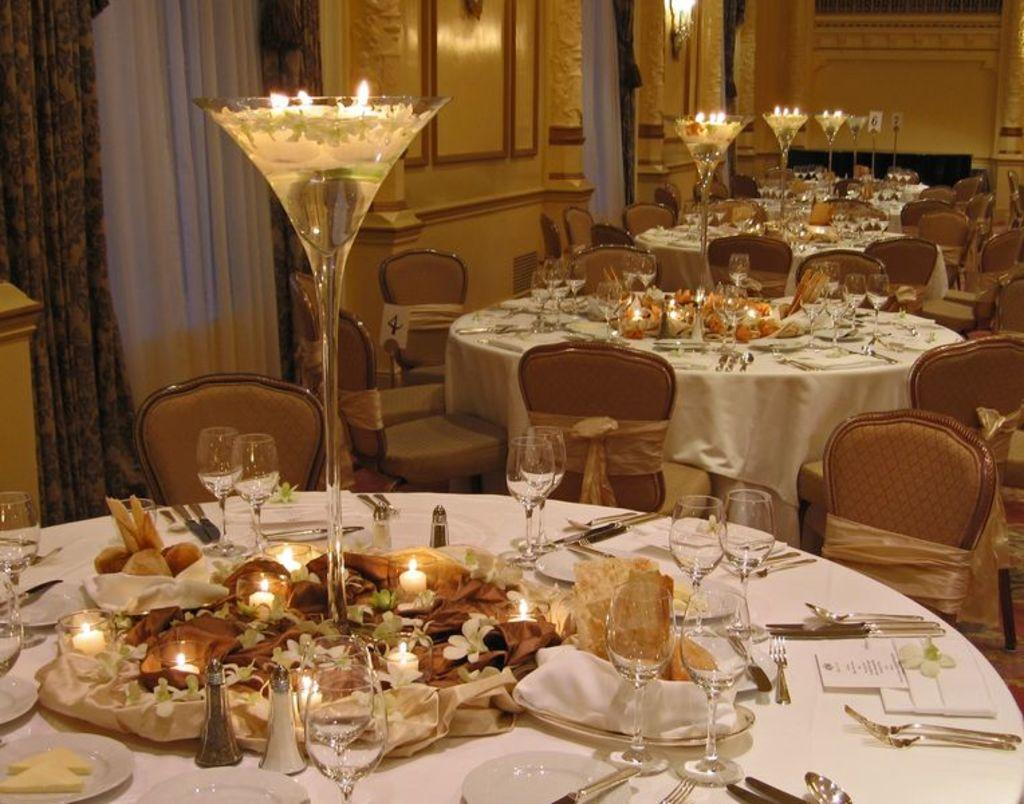What type of window treatment is visible in the image? There are curtains in the image. What type of furniture is present in the image? There are tables and chairs in the image. What objects can be seen on the tables? There are glasses and candles on the tables. What type of sign can be seen hanging from the quill in the image? There is no sign or quill present in the image. How many doors are visible in the image? There are no doors visible in the image. 